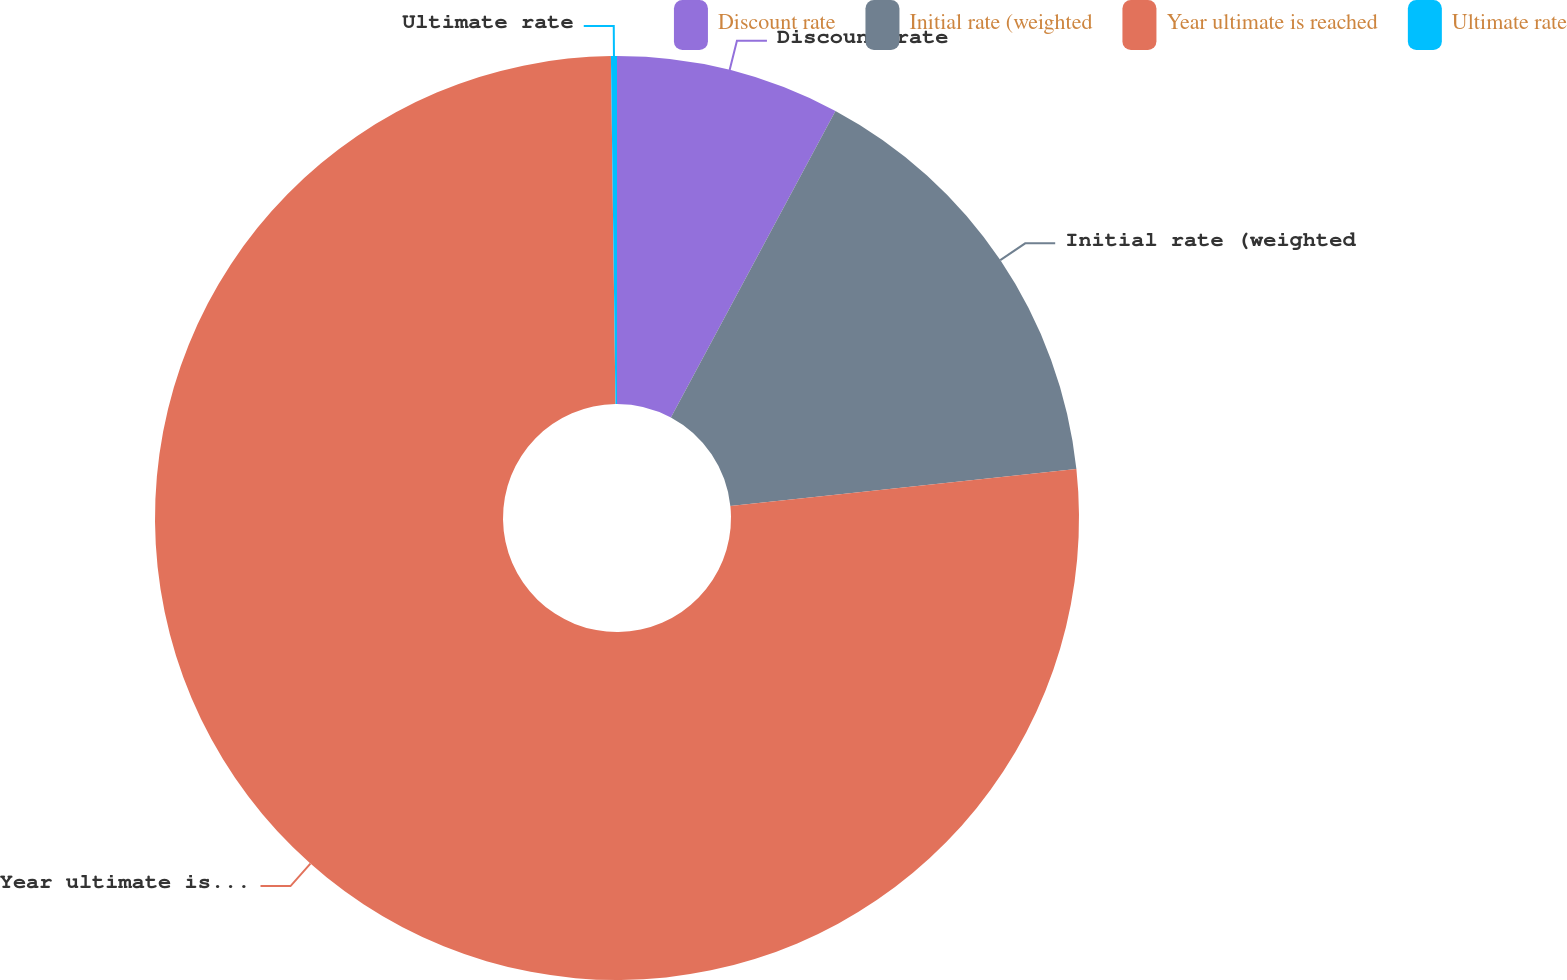Convert chart to OTSL. <chart><loc_0><loc_0><loc_500><loc_500><pie_chart><fcel>Discount rate<fcel>Initial rate (weighted<fcel>Year ultimate is reached<fcel>Ultimate rate<nl><fcel>7.84%<fcel>15.47%<fcel>76.49%<fcel>0.21%<nl></chart> 